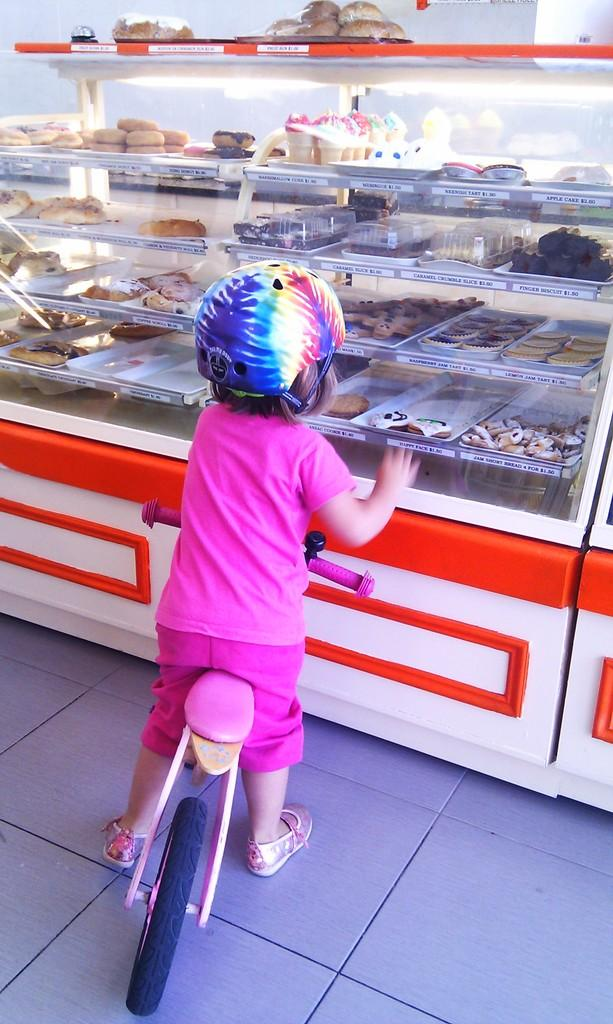What is the main subject of the picture? The main subject of the picture is a small kid. What is the kid doing in the picture? The kid is sitting on a bicycle. What is the kid wearing in the picture? The kid is wearing a pink dress and a helmet on her head. What is the setting of the picture? The kid is standing in front of bakery food items. What type of silverware can be seen in the picture? There is no silverware present in the picture; it features a small kid sitting on a bicycle in front of bakery food items. 